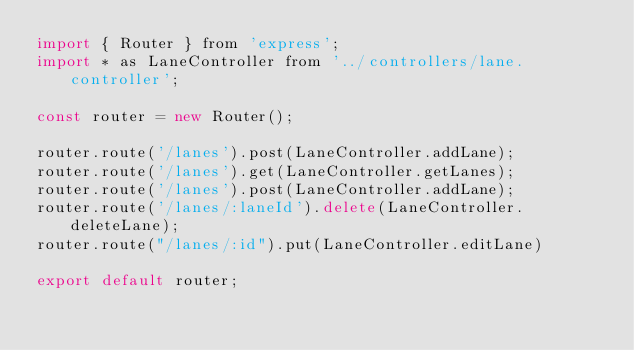<code> <loc_0><loc_0><loc_500><loc_500><_JavaScript_>import { Router } from 'express';
import * as LaneController from '../controllers/lane.controller';

const router = new Router();

router.route('/lanes').post(LaneController.addLane);
router.route('/lanes').get(LaneController.getLanes);
router.route('/lanes').post(LaneController.addLane);
router.route('/lanes/:laneId').delete(LaneController.deleteLane);
router.route("/lanes/:id").put(LaneController.editLane)

export default router;</code> 